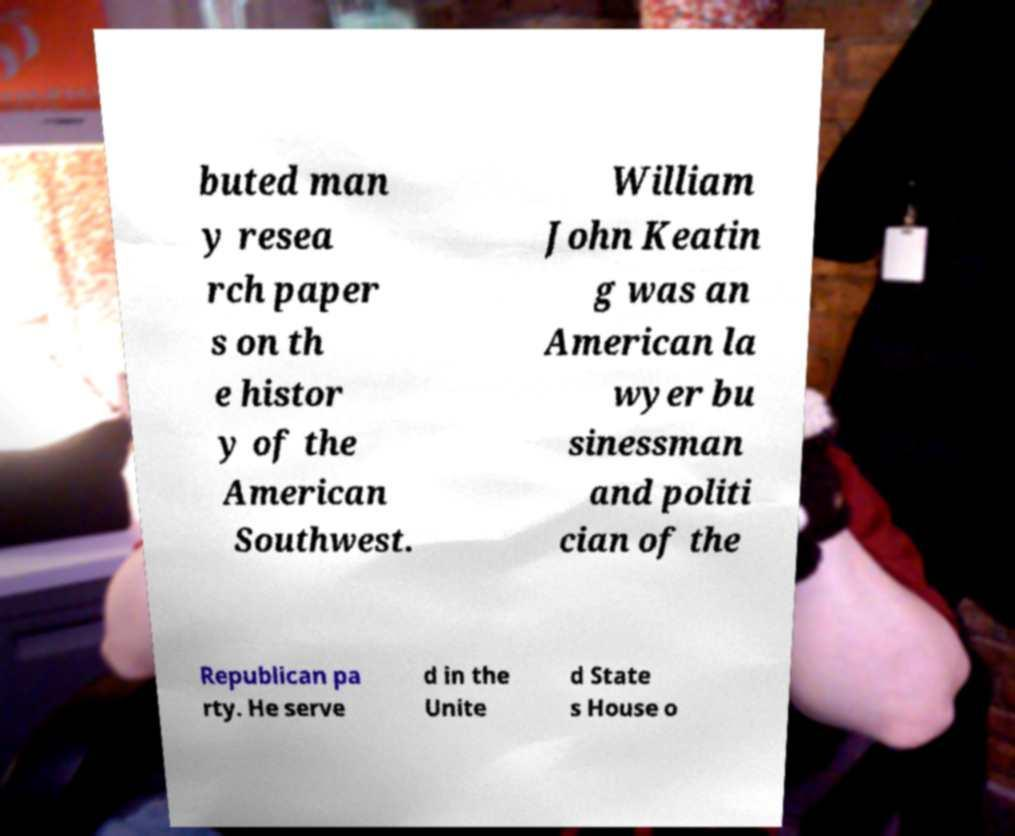There's text embedded in this image that I need extracted. Can you transcribe it verbatim? buted man y resea rch paper s on th e histor y of the American Southwest. William John Keatin g was an American la wyer bu sinessman and politi cian of the Republican pa rty. He serve d in the Unite d State s House o 